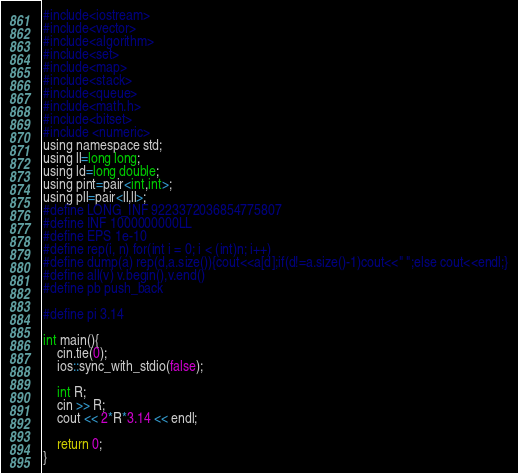<code> <loc_0><loc_0><loc_500><loc_500><_C_>#include<iostream>
#include<vector>
#include<algorithm>
#include<set>
#include<map>
#include<stack>
#include<queue>
#include<math.h>
#include<bitset>
#include <numeric>
using namespace std;
using ll=long long;
using ld=long double;
using pint=pair<int,int>;
using pll=pair<ll,ll>;
#define LONG_INF 9223372036854775807
#define INF 1000000000LL
#define EPS 1e-10
#define rep(i, n) for(int i = 0; i < (int)n; i++)
#define dump(a) rep(d,a.size()){cout<<a[d];if(d!=a.size()-1)cout<<" ";else cout<<endl;}
#define all(v) v.begin(),v.end()
#define pb push_back

#define pi 3.14

int main(){
    cin.tie(0);
    ios::sync_with_stdio(false);

    int R;
    cin >> R;
    cout << 2*R*3.14 << endl;

    return 0;
}</code> 